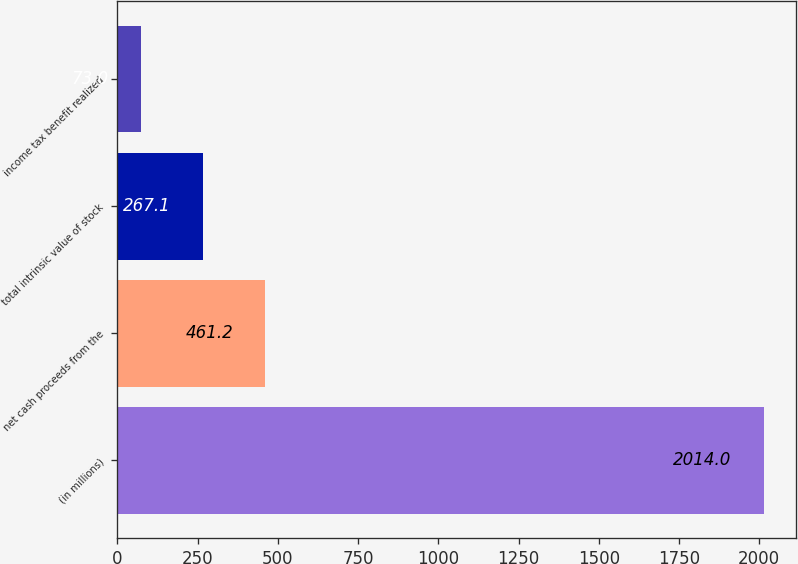<chart> <loc_0><loc_0><loc_500><loc_500><bar_chart><fcel>(in millions)<fcel>net cash proceeds from the<fcel>total intrinsic value of stock<fcel>income tax benefit realized<nl><fcel>2014<fcel>461.2<fcel>267.1<fcel>73<nl></chart> 